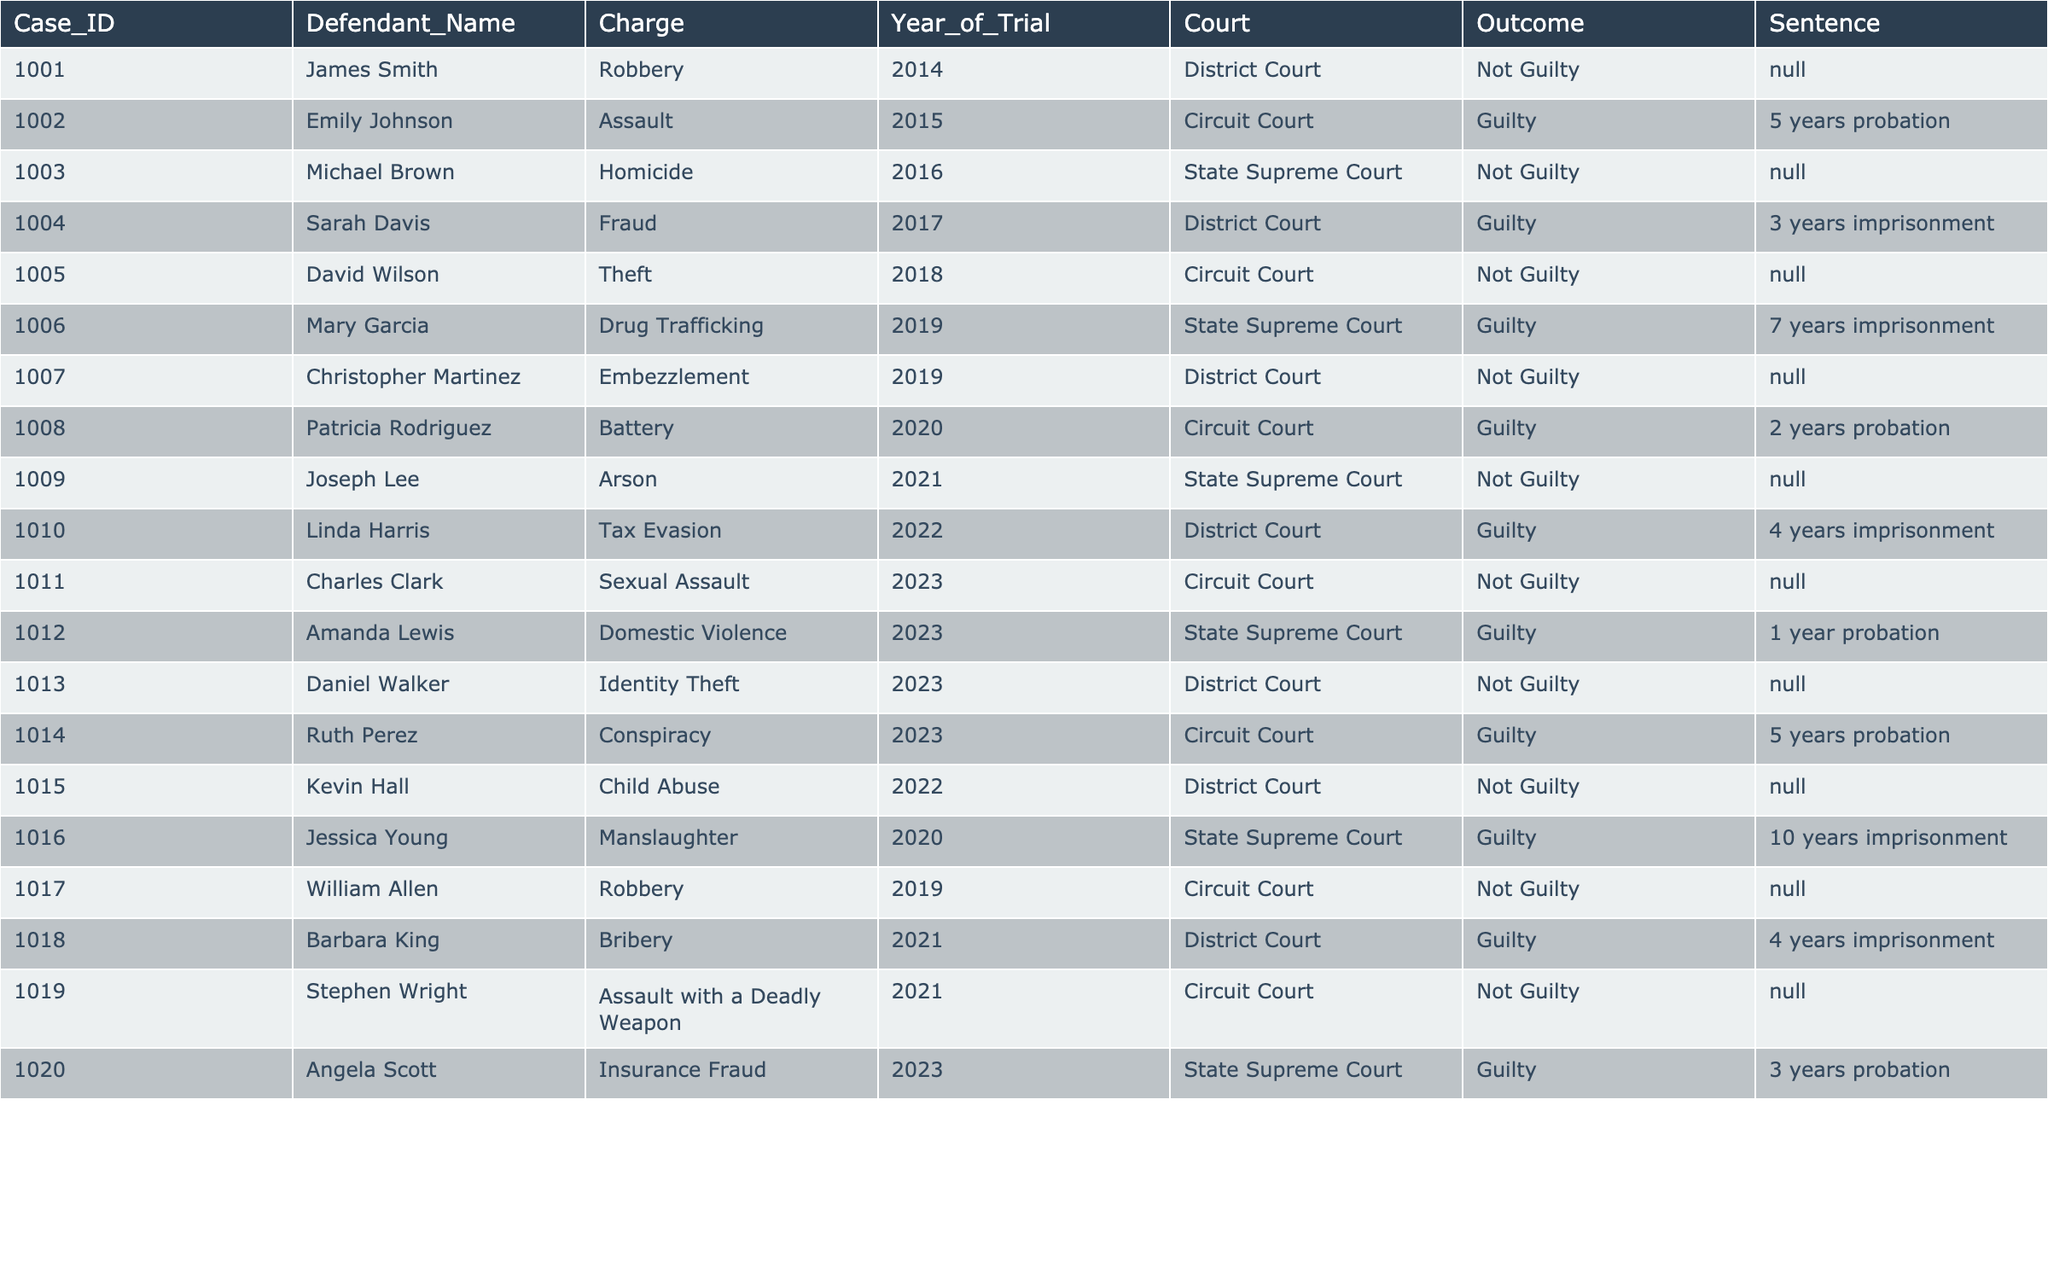What is the total number of cases where the outcome was Not Guilty? There are 7 cases with the outcome "Not Guilty" marked in the table. We can count them: 1001, 1003, 1005, 1007, 1009, 1011, and 1013.
Answer: 7 How many defendants received imprisonment sentences? There are 5 cases where defendants received imprisonment sentences. The sentences are found in the rows for Sarah Davis, Mary Garcia, Jessica Young, Barbara King, and Linda Harris.
Answer: 5 What is the outcome of Daniel Walker's case? The row for Daniel Walker shows that his case was judged as "Not Guilty." This is determined by looking at the Outcome column for his Case_ID 1013.
Answer: Not Guilty Who had the longest probation sentence among guilty verdicts? Mary Garcia received a 7-year imprisonment sentence, Patricia Rodriguez received a 2-year probation sentence, and Amanda Lewis received a 1-year probation sentence. Ruth Perez also received a 5-year probation. Among these, the longest probation is 5 years, which is given to Ruth Perez.
Answer: 5 years What percentage of trials resulted in a Not Guilty verdict? There were 20 total cases, and 7 of them resulted in a Not Guilty verdict. To find the percentage, we calculate (7/20)*100 = 35%.
Answer: 35% Is there any case where the charge was Robbery and the verdict was Guilty? Reviewing the table, only one case had the charge of Robbery: James Smith’s case, which had a verdict of Not Guilty. Thus, there are no cases with the charge of Robbery that resulted in a Guilty verdict.
Answer: No In 2023, how many trials resulted in a Guilty verdict? There are 2 cases from the year 2023, where Amanda Lewis and Ruth Perez had Guilty outcomes. The count of Guilty outcomes in that year is therefore 2.
Answer: 2 What was the average sentence duration for cases with a Guilty verdict? Calculating the total time from imprisonment and probation sentences: 5 (Emily Johnson) + 3 (Sarah Davis) + 7 (Mary Garcia) + 2 (Patricia Rodriguez) + 4 (Linda Harris) + 1 (Amanda Lewis) + 5 (Ruth Perez) + 10 (Jessica Young) + 4 (Barbara King) = 37 years. There are 9 guilty verdicts total, so the average is 37/9 ≈ 4.11 years.
Answer: Approximately 4.11 years Which court had the most Not Guilty verdicts? The District Court recorded 4 Not Guilty outcomes (Cases 1001, 1005, 1007, and 1013), which is the highest count compared to other courts.
Answer: District Court Was there ever a case where both the charge and the outcome were the same for the same defendant? Looking through the table, there are no cases where the charge matches the outcome in terms of similar descriptive elements (a guilty verdict does not align with the charge as they differ). All charges judged resulted in either Guilty or Not Guilty verdicts.
Answer: No 